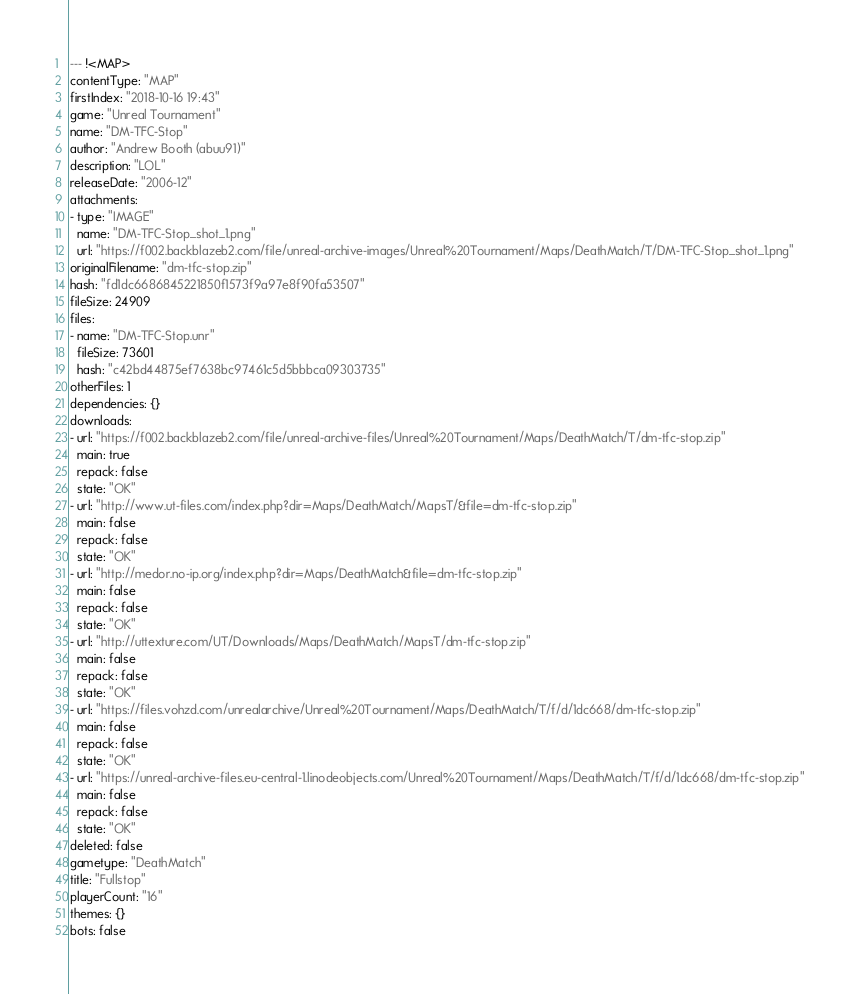Convert code to text. <code><loc_0><loc_0><loc_500><loc_500><_YAML_>--- !<MAP>
contentType: "MAP"
firstIndex: "2018-10-16 19:43"
game: "Unreal Tournament"
name: "DM-TFC-Stop"
author: "Andrew Booth (abuu91)"
description: "LOL"
releaseDate: "2006-12"
attachments:
- type: "IMAGE"
  name: "DM-TFC-Stop_shot_1.png"
  url: "https://f002.backblazeb2.com/file/unreal-archive-images/Unreal%20Tournament/Maps/DeathMatch/T/DM-TFC-Stop_shot_1.png"
originalFilename: "dm-tfc-stop.zip"
hash: "fd1dc6686845221850f1573f9a97e8f90fa53507"
fileSize: 24909
files:
- name: "DM-TFC-Stop.unr"
  fileSize: 73601
  hash: "c42bd44875ef7638bc97461c5d5bbbca09303735"
otherFiles: 1
dependencies: {}
downloads:
- url: "https://f002.backblazeb2.com/file/unreal-archive-files/Unreal%20Tournament/Maps/DeathMatch/T/dm-tfc-stop.zip"
  main: true
  repack: false
  state: "OK"
- url: "http://www.ut-files.com/index.php?dir=Maps/DeathMatch/MapsT/&file=dm-tfc-stop.zip"
  main: false
  repack: false
  state: "OK"
- url: "http://medor.no-ip.org/index.php?dir=Maps/DeathMatch&file=dm-tfc-stop.zip"
  main: false
  repack: false
  state: "OK"
- url: "http://uttexture.com/UT/Downloads/Maps/DeathMatch/MapsT/dm-tfc-stop.zip"
  main: false
  repack: false
  state: "OK"
- url: "https://files.vohzd.com/unrealarchive/Unreal%20Tournament/Maps/DeathMatch/T/f/d/1dc668/dm-tfc-stop.zip"
  main: false
  repack: false
  state: "OK"
- url: "https://unreal-archive-files.eu-central-1.linodeobjects.com/Unreal%20Tournament/Maps/DeathMatch/T/f/d/1dc668/dm-tfc-stop.zip"
  main: false
  repack: false
  state: "OK"
deleted: false
gametype: "DeathMatch"
title: "Fullstop"
playerCount: "16"
themes: {}
bots: false
</code> 